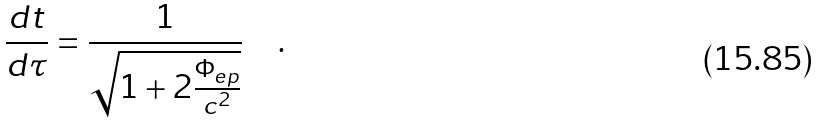<formula> <loc_0><loc_0><loc_500><loc_500>\frac { d t } { d \tau } = \frac { 1 } { \sqrt { 1 + 2 \frac { \Phi _ { e p } } { c ^ { 2 } } } } \quad .</formula> 